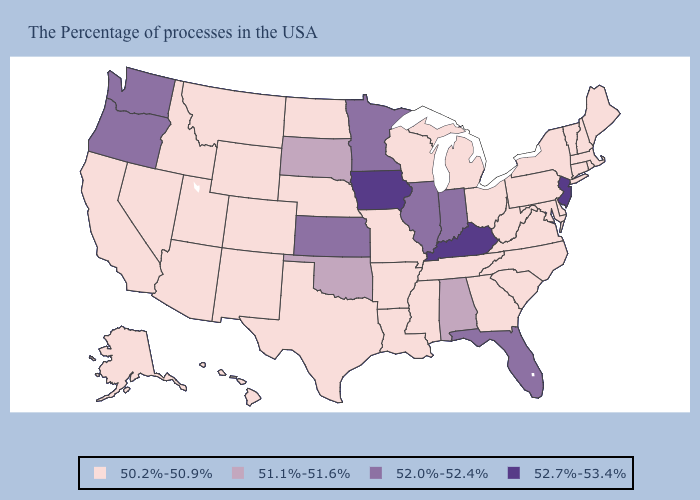Name the states that have a value in the range 51.1%-51.6%?
Give a very brief answer. Alabama, Oklahoma, South Dakota. Is the legend a continuous bar?
Concise answer only. No. Which states have the lowest value in the South?
Quick response, please. Delaware, Maryland, Virginia, North Carolina, South Carolina, West Virginia, Georgia, Tennessee, Mississippi, Louisiana, Arkansas, Texas. Does Mississippi have the same value as Washington?
Short answer required. No. What is the value of New York?
Concise answer only. 50.2%-50.9%. What is the value of Utah?
Short answer required. 50.2%-50.9%. What is the value of Connecticut?
Give a very brief answer. 50.2%-50.9%. Among the states that border Indiana , which have the highest value?
Write a very short answer. Kentucky. Name the states that have a value in the range 51.1%-51.6%?
Write a very short answer. Alabama, Oklahoma, South Dakota. Name the states that have a value in the range 52.0%-52.4%?
Concise answer only. Florida, Indiana, Illinois, Minnesota, Kansas, Washington, Oregon. What is the highest value in states that border North Carolina?
Answer briefly. 50.2%-50.9%. What is the value of Colorado?
Short answer required. 50.2%-50.9%. Name the states that have a value in the range 52.0%-52.4%?
Short answer required. Florida, Indiana, Illinois, Minnesota, Kansas, Washington, Oregon. 